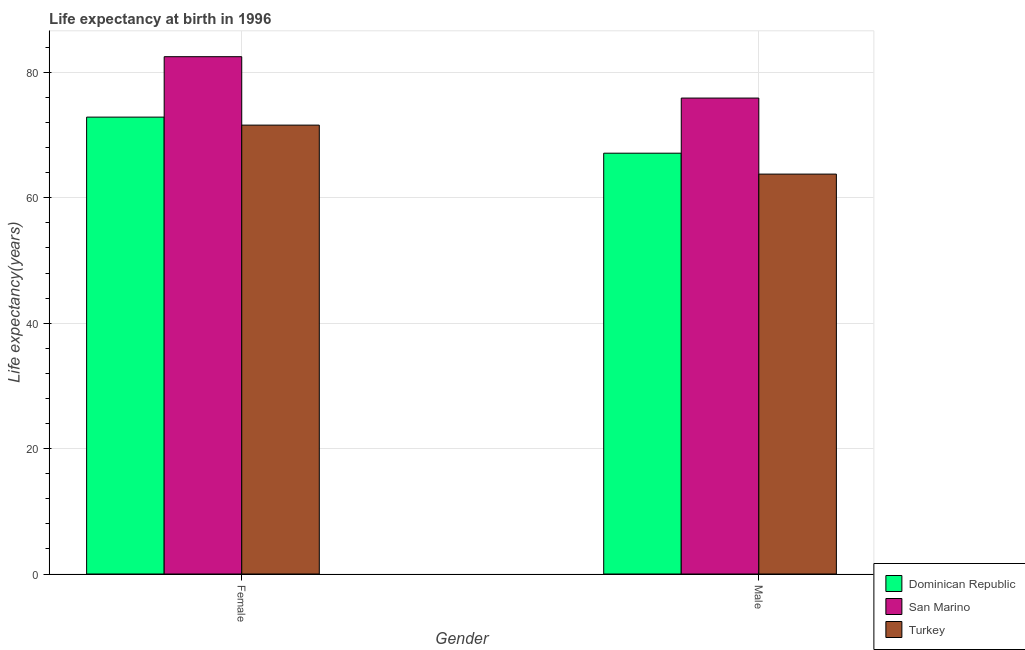Are the number of bars per tick equal to the number of legend labels?
Offer a terse response. Yes. What is the label of the 1st group of bars from the left?
Offer a terse response. Female. What is the life expectancy(male) in Turkey?
Provide a succinct answer. 63.77. Across all countries, what is the maximum life expectancy(female)?
Give a very brief answer. 82.5. Across all countries, what is the minimum life expectancy(female)?
Offer a very short reply. 71.59. In which country was the life expectancy(male) maximum?
Your response must be concise. San Marino. What is the total life expectancy(female) in the graph?
Make the answer very short. 226.95. What is the difference between the life expectancy(female) in Dominican Republic and that in Turkey?
Ensure brevity in your answer.  1.27. What is the difference between the life expectancy(female) in Turkey and the life expectancy(male) in San Marino?
Ensure brevity in your answer.  -4.31. What is the average life expectancy(female) per country?
Ensure brevity in your answer.  75.65. What is the difference between the life expectancy(female) and life expectancy(male) in Turkey?
Provide a short and direct response. 7.81. What is the ratio of the life expectancy(female) in Turkey to that in San Marino?
Provide a short and direct response. 0.87. Is the life expectancy(female) in San Marino less than that in Dominican Republic?
Provide a succinct answer. No. What does the 3rd bar from the left in Female represents?
Your answer should be very brief. Turkey. What does the 3rd bar from the right in Male represents?
Give a very brief answer. Dominican Republic. Does the graph contain any zero values?
Give a very brief answer. No. Where does the legend appear in the graph?
Your answer should be compact. Bottom right. What is the title of the graph?
Keep it short and to the point. Life expectancy at birth in 1996. What is the label or title of the Y-axis?
Make the answer very short. Life expectancy(years). What is the Life expectancy(years) of Dominican Republic in Female?
Keep it short and to the point. 72.86. What is the Life expectancy(years) of San Marino in Female?
Keep it short and to the point. 82.5. What is the Life expectancy(years) in Turkey in Female?
Your answer should be very brief. 71.59. What is the Life expectancy(years) of Dominican Republic in Male?
Offer a terse response. 67.11. What is the Life expectancy(years) in San Marino in Male?
Make the answer very short. 75.9. What is the Life expectancy(years) in Turkey in Male?
Give a very brief answer. 63.77. Across all Gender, what is the maximum Life expectancy(years) of Dominican Republic?
Make the answer very short. 72.86. Across all Gender, what is the maximum Life expectancy(years) in San Marino?
Give a very brief answer. 82.5. Across all Gender, what is the maximum Life expectancy(years) of Turkey?
Ensure brevity in your answer.  71.59. Across all Gender, what is the minimum Life expectancy(years) in Dominican Republic?
Provide a succinct answer. 67.11. Across all Gender, what is the minimum Life expectancy(years) of San Marino?
Your response must be concise. 75.9. Across all Gender, what is the minimum Life expectancy(years) in Turkey?
Keep it short and to the point. 63.77. What is the total Life expectancy(years) in Dominican Republic in the graph?
Provide a short and direct response. 139.97. What is the total Life expectancy(years) in San Marino in the graph?
Provide a short and direct response. 158.4. What is the total Life expectancy(years) in Turkey in the graph?
Make the answer very short. 135.36. What is the difference between the Life expectancy(years) of Dominican Republic in Female and that in Male?
Ensure brevity in your answer.  5.75. What is the difference between the Life expectancy(years) of Turkey in Female and that in Male?
Your answer should be very brief. 7.81. What is the difference between the Life expectancy(years) in Dominican Republic in Female and the Life expectancy(years) in San Marino in Male?
Provide a succinct answer. -3.04. What is the difference between the Life expectancy(years) of Dominican Republic in Female and the Life expectancy(years) of Turkey in Male?
Offer a terse response. 9.09. What is the difference between the Life expectancy(years) in San Marino in Female and the Life expectancy(years) in Turkey in Male?
Your answer should be very brief. 18.73. What is the average Life expectancy(years) in Dominican Republic per Gender?
Keep it short and to the point. 69.99. What is the average Life expectancy(years) of San Marino per Gender?
Keep it short and to the point. 79.2. What is the average Life expectancy(years) in Turkey per Gender?
Your response must be concise. 67.68. What is the difference between the Life expectancy(years) of Dominican Republic and Life expectancy(years) of San Marino in Female?
Provide a short and direct response. -9.64. What is the difference between the Life expectancy(years) in Dominican Republic and Life expectancy(years) in Turkey in Female?
Keep it short and to the point. 1.27. What is the difference between the Life expectancy(years) in San Marino and Life expectancy(years) in Turkey in Female?
Your answer should be compact. 10.91. What is the difference between the Life expectancy(years) in Dominican Republic and Life expectancy(years) in San Marino in Male?
Your answer should be compact. -8.79. What is the difference between the Life expectancy(years) of Dominican Republic and Life expectancy(years) of Turkey in Male?
Make the answer very short. 3.33. What is the difference between the Life expectancy(years) of San Marino and Life expectancy(years) of Turkey in Male?
Your response must be concise. 12.12. What is the ratio of the Life expectancy(years) of Dominican Republic in Female to that in Male?
Your response must be concise. 1.09. What is the ratio of the Life expectancy(years) in San Marino in Female to that in Male?
Keep it short and to the point. 1.09. What is the ratio of the Life expectancy(years) of Turkey in Female to that in Male?
Your answer should be very brief. 1.12. What is the difference between the highest and the second highest Life expectancy(years) in Dominican Republic?
Keep it short and to the point. 5.75. What is the difference between the highest and the second highest Life expectancy(years) of San Marino?
Offer a very short reply. 6.6. What is the difference between the highest and the second highest Life expectancy(years) in Turkey?
Make the answer very short. 7.81. What is the difference between the highest and the lowest Life expectancy(years) of Dominican Republic?
Make the answer very short. 5.75. What is the difference between the highest and the lowest Life expectancy(years) in San Marino?
Make the answer very short. 6.6. What is the difference between the highest and the lowest Life expectancy(years) of Turkey?
Make the answer very short. 7.81. 